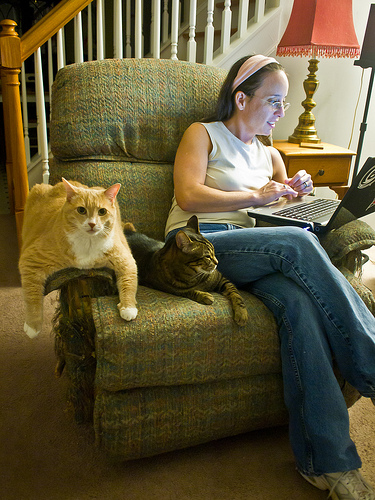<image>
Is there a cat behind the women? No. The cat is not behind the women. From this viewpoint, the cat appears to be positioned elsewhere in the scene. 